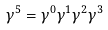<formula> <loc_0><loc_0><loc_500><loc_500>\gamma ^ { 5 } = \gamma ^ { 0 } \gamma ^ { 1 } \gamma ^ { 2 } \gamma ^ { 3 }</formula> 